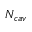Convert formula to latex. <formula><loc_0><loc_0><loc_500><loc_500>N _ { c a v }</formula> 